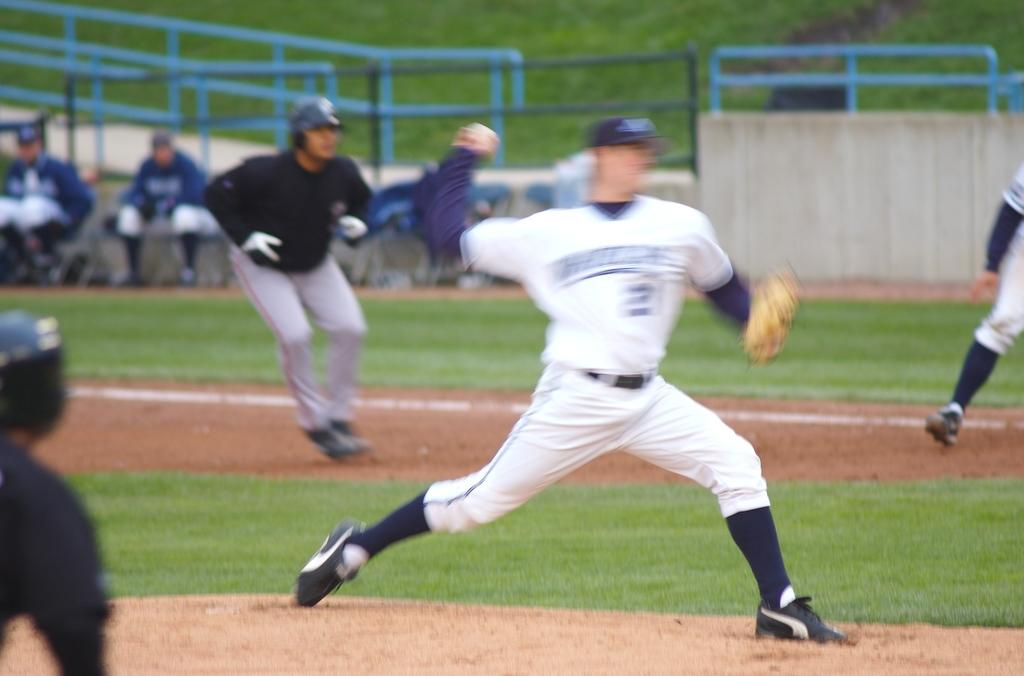How many people are in the image? There are persons in the image, but the exact number is not specified. What type of surface is visible in the image? There is grass and rocky land visible in the image. What type of material are the iron objects made of? The iron objects in the image are made of iron. What is the background of the image? There is a wall in the image, which serves as the background. What other objects can be seen in the image? There are other objects in the image, but their specific nature is not mentioned. What color is the daughter's dress in the image? There is no mention of a daughter or a dress in the image, so this question cannot be answered. 